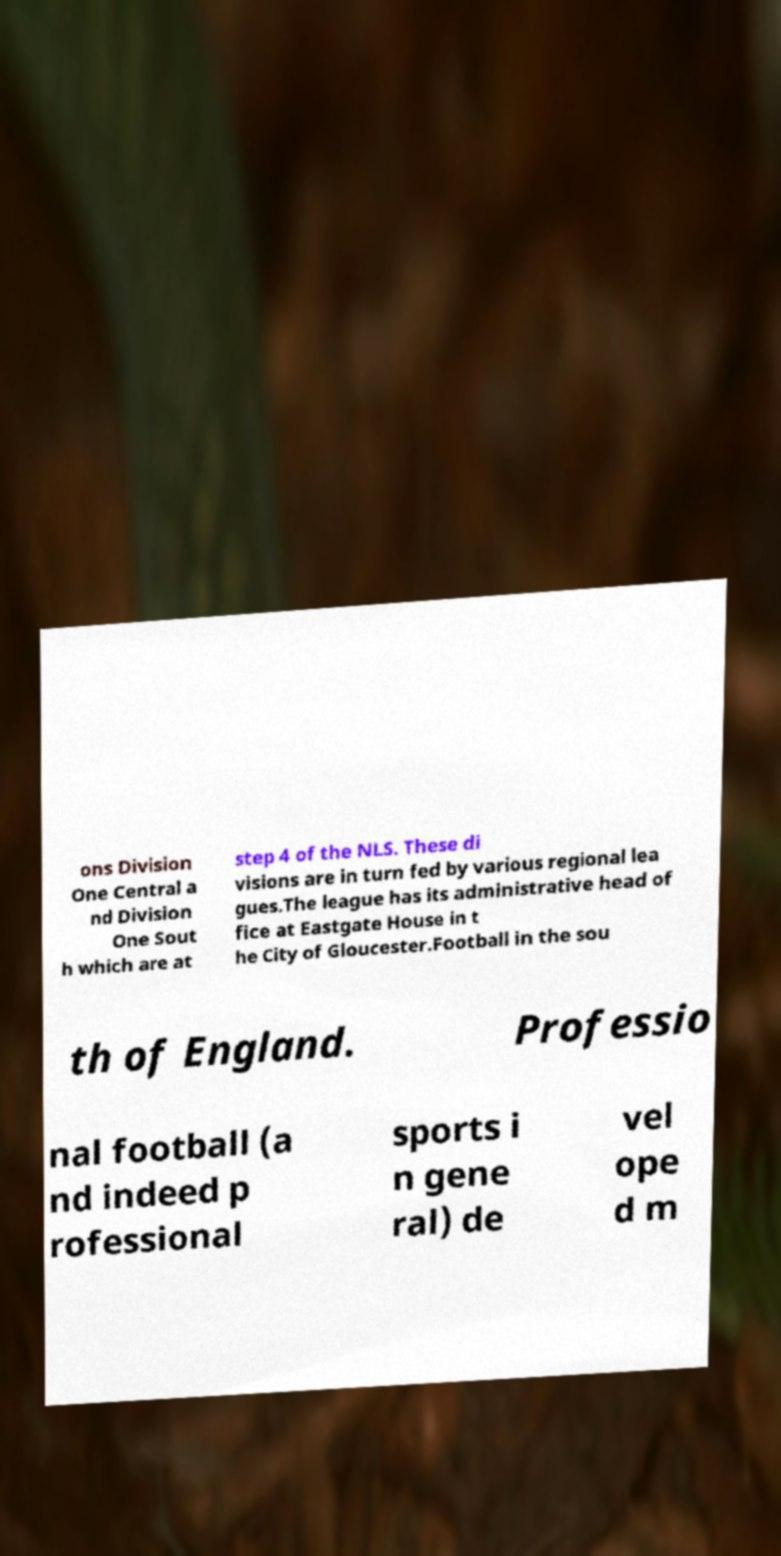Please read and relay the text visible in this image. What does it say? ons Division One Central a nd Division One Sout h which are at step 4 of the NLS. These di visions are in turn fed by various regional lea gues.The league has its administrative head of fice at Eastgate House in t he City of Gloucester.Football in the sou th of England. Professio nal football (a nd indeed p rofessional sports i n gene ral) de vel ope d m 